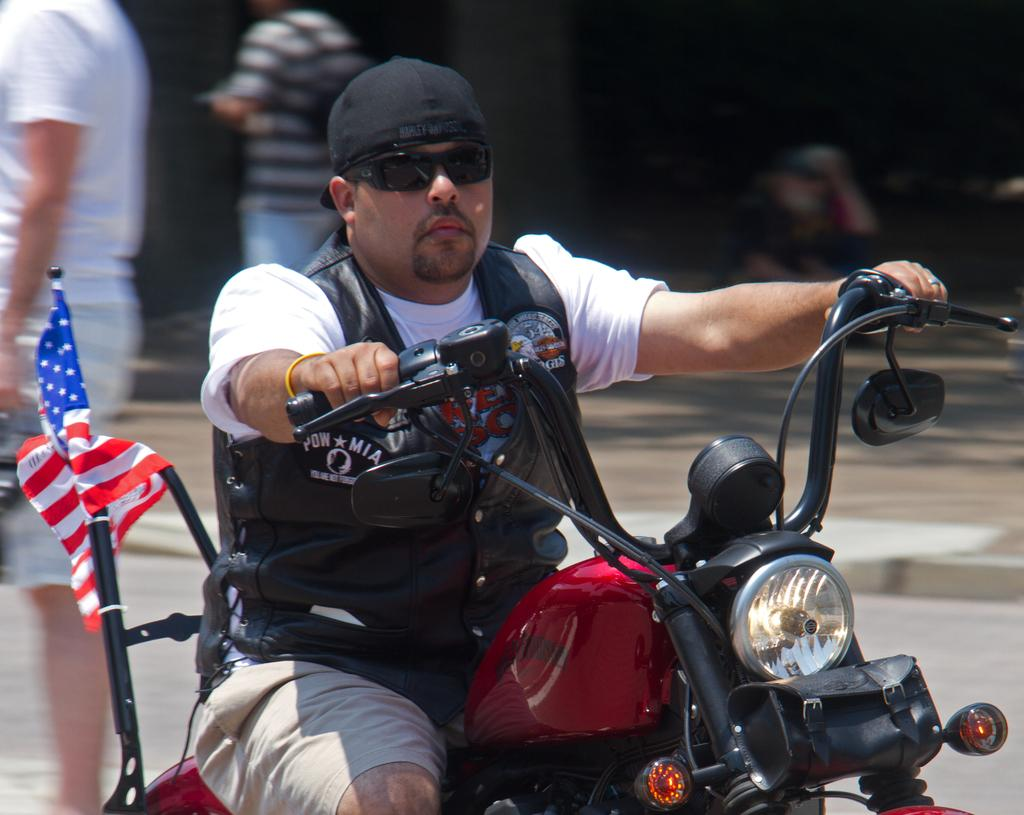What is the main subject of the image? There is a man in the image. What is the man doing in the image? The man is riding a motorbike. Can you describe the background of the image? There are people in the background of the image. What type of nerve can be seen connecting the motorbike to the man in the image? There are no visible nerves connecting the man to the motorbike in the image. 